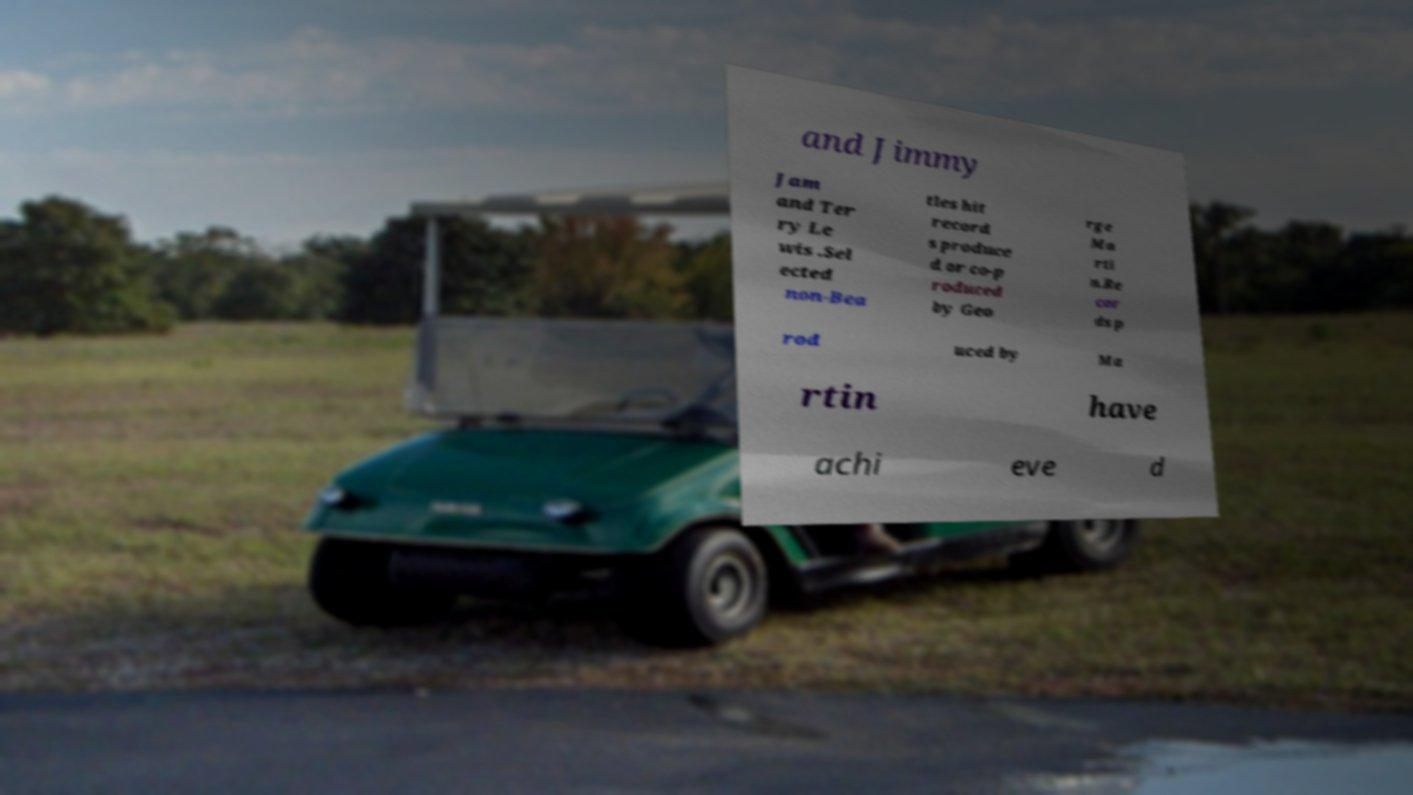Could you assist in decoding the text presented in this image and type it out clearly? and Jimmy Jam and Ter ry Le wis .Sel ected non-Bea tles hit record s produce d or co-p roduced by Geo rge Ma rti n.Re cor ds p rod uced by Ma rtin have achi eve d 